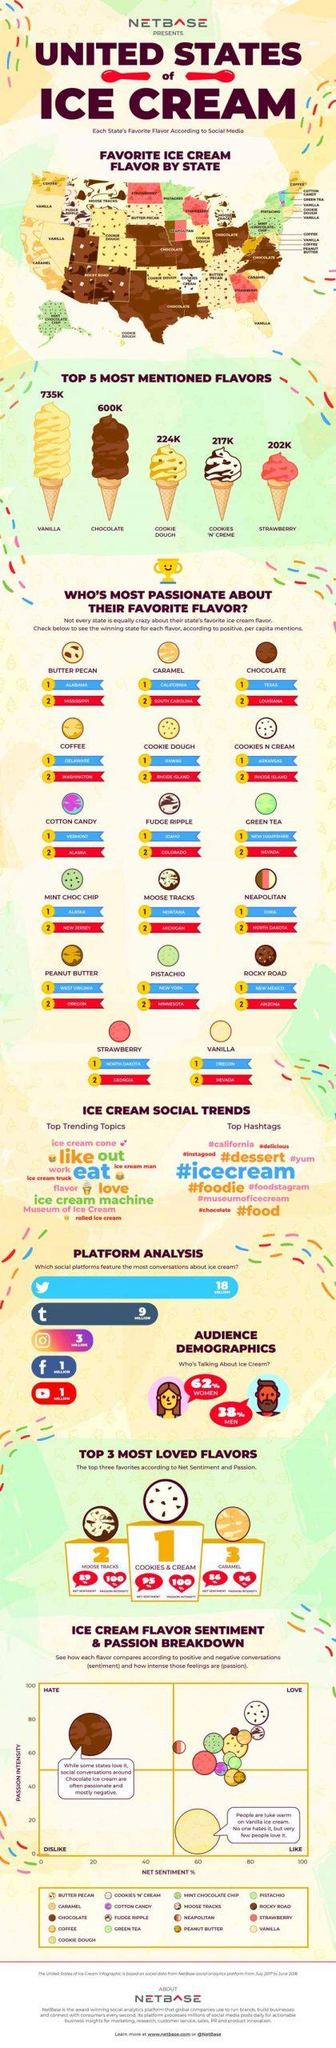List a handful of essential elements in this visual. There were 735,000 mentions of vanilla flavor. The top trending hashtag is #icecream. Based on the information available, it can be declared that the social media platform that features the most conversations about ice cream is Twitter. According to a large dataset, strawberry flavor has 202K mentions. The second most frequently mentioned ice cream flavor is chocolate 